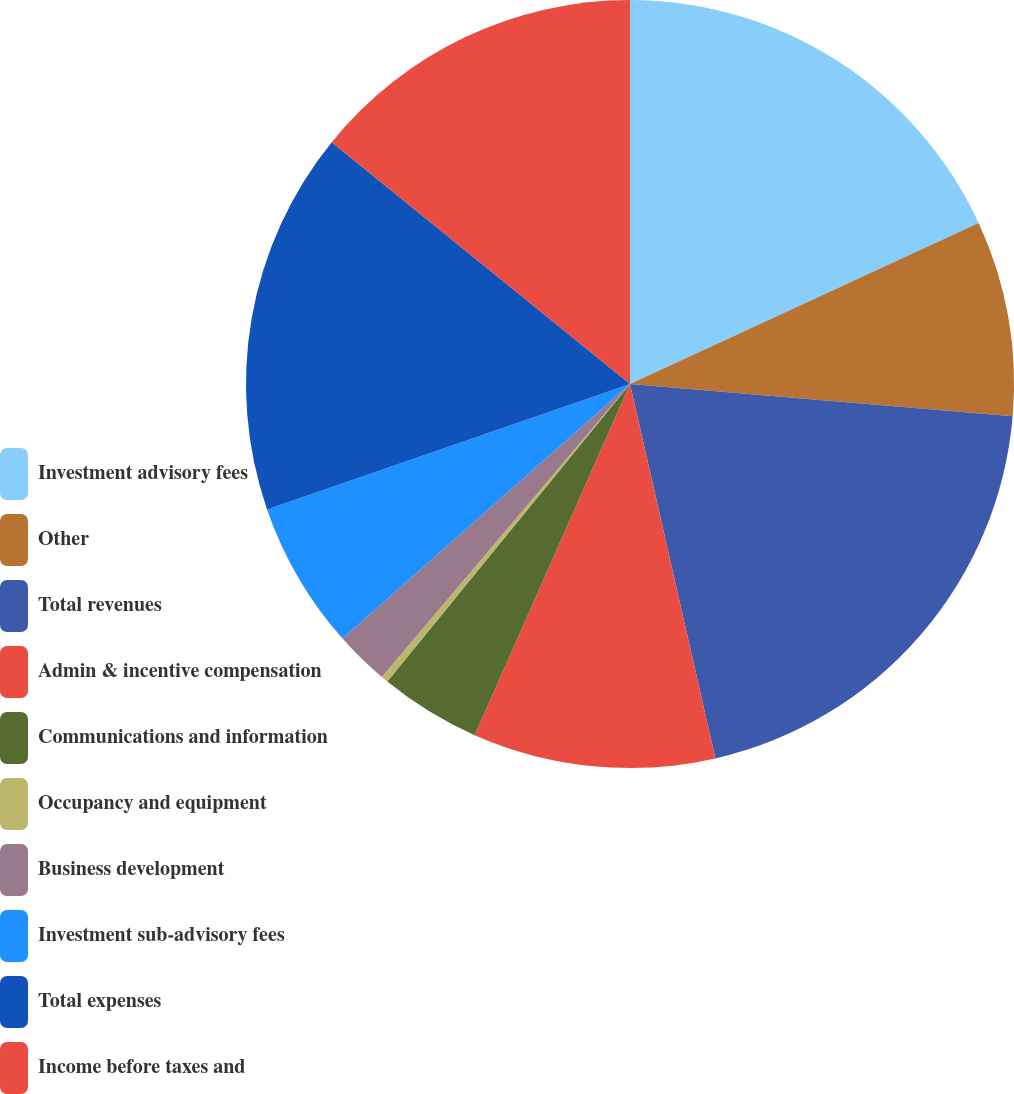Convert chart to OTSL. <chart><loc_0><loc_0><loc_500><loc_500><pie_chart><fcel>Investment advisory fees<fcel>Other<fcel>Total revenues<fcel>Admin & incentive compensation<fcel>Communications and information<fcel>Occupancy and equipment<fcel>Business development<fcel>Investment sub-advisory fees<fcel>Total expenses<fcel>Income before taxes and<nl><fcel>18.12%<fcel>8.22%<fcel>20.1%<fcel>10.2%<fcel>4.26%<fcel>0.3%<fcel>2.28%<fcel>6.24%<fcel>16.14%<fcel>14.16%<nl></chart> 